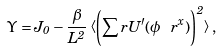Convert formula to latex. <formula><loc_0><loc_0><loc_500><loc_500>\Upsilon = J _ { 0 } - \frac { \beta } { L ^ { 2 } } \left < \left ( \sum _ { \ } r U ^ { \prime } ( \phi _ { \ } r ^ { x } ) \right ) ^ { 2 } \right > ,</formula> 